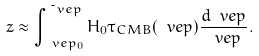Convert formula to latex. <formula><loc_0><loc_0><loc_500><loc_500>z \approx \int _ { \ v e p _ { 0 } } ^ { \tilde { \ } v e p } H _ { 0 } \tau _ { C M B } ( \ v e p ) \frac { d \ v e p } { \ v e p } .</formula> 